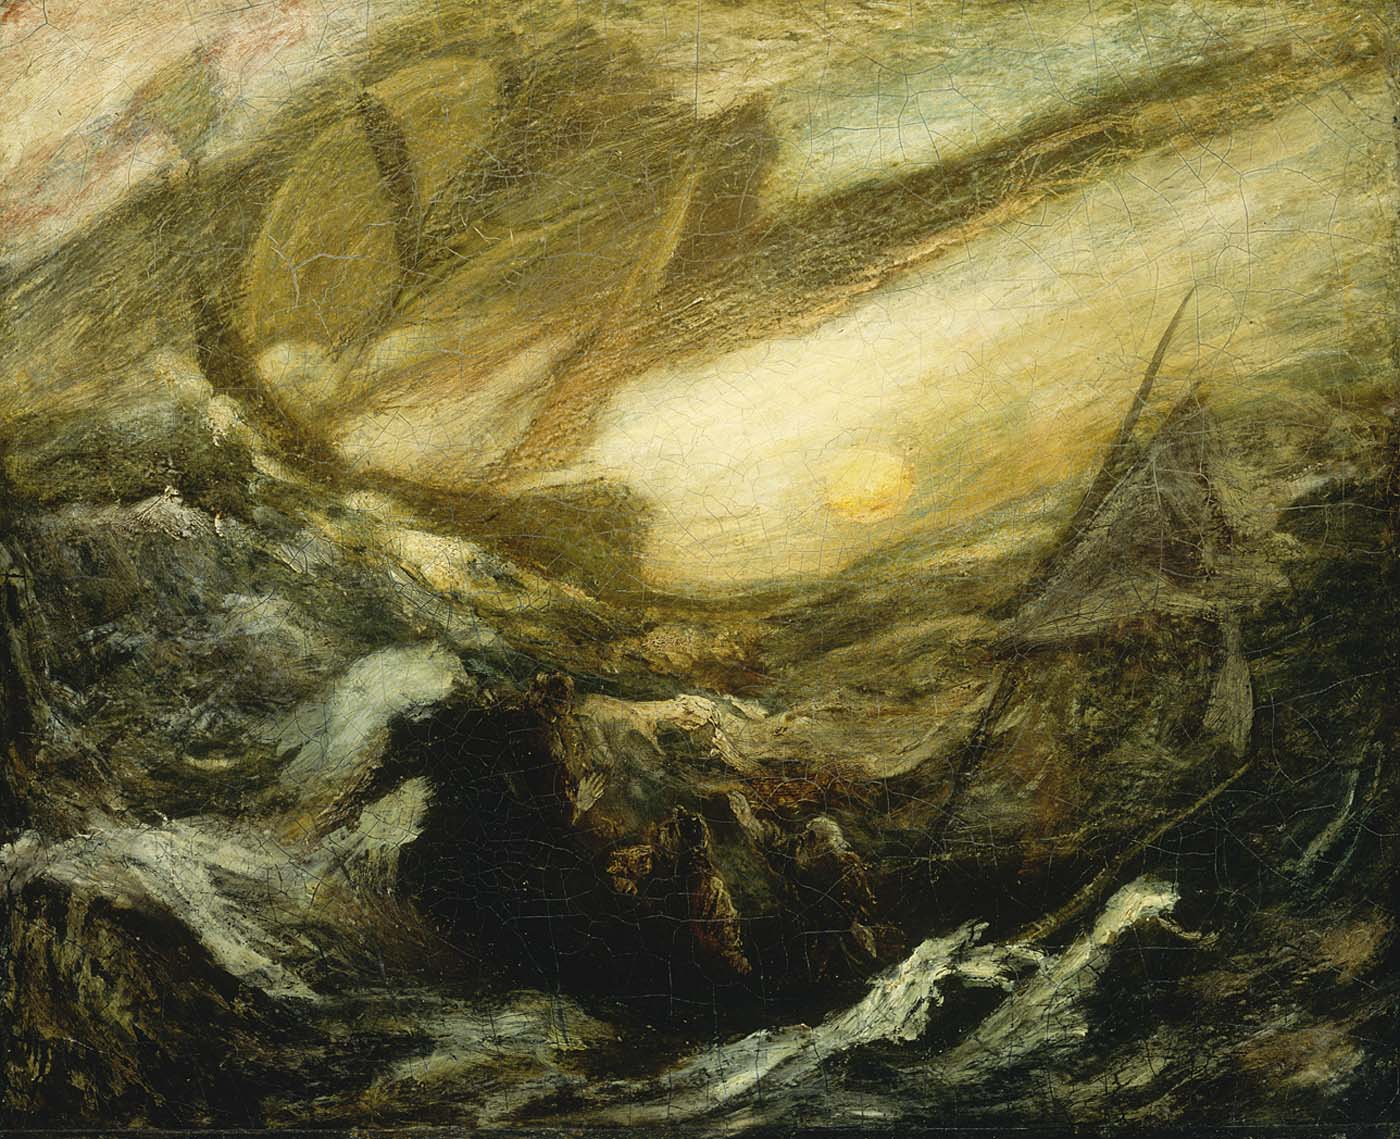Imagine you are a sailor in this scene. Describe your experience and thoughts. As a sailor caught in the midst of this scene, the experience is overwhelming and deeply visceral. The howling winds and towering waves batter our ship, each surge threatening to pull us into the abyss. The sea seems alive, a monstrous entity intent on swallowing us whole. Yet amidst the chaos, a part of me is transfixed by the radiant sun breaking through the dark clouds, a symbol of hope that we can survive this ordeal. Fear and awe intermingle as we navigate the treacherous waters, relying on every ounce of skill and determination. It's a moment of pure adrenaline, where survival hinges on the razor's edge of nature's fury and our resolve to persevere. 